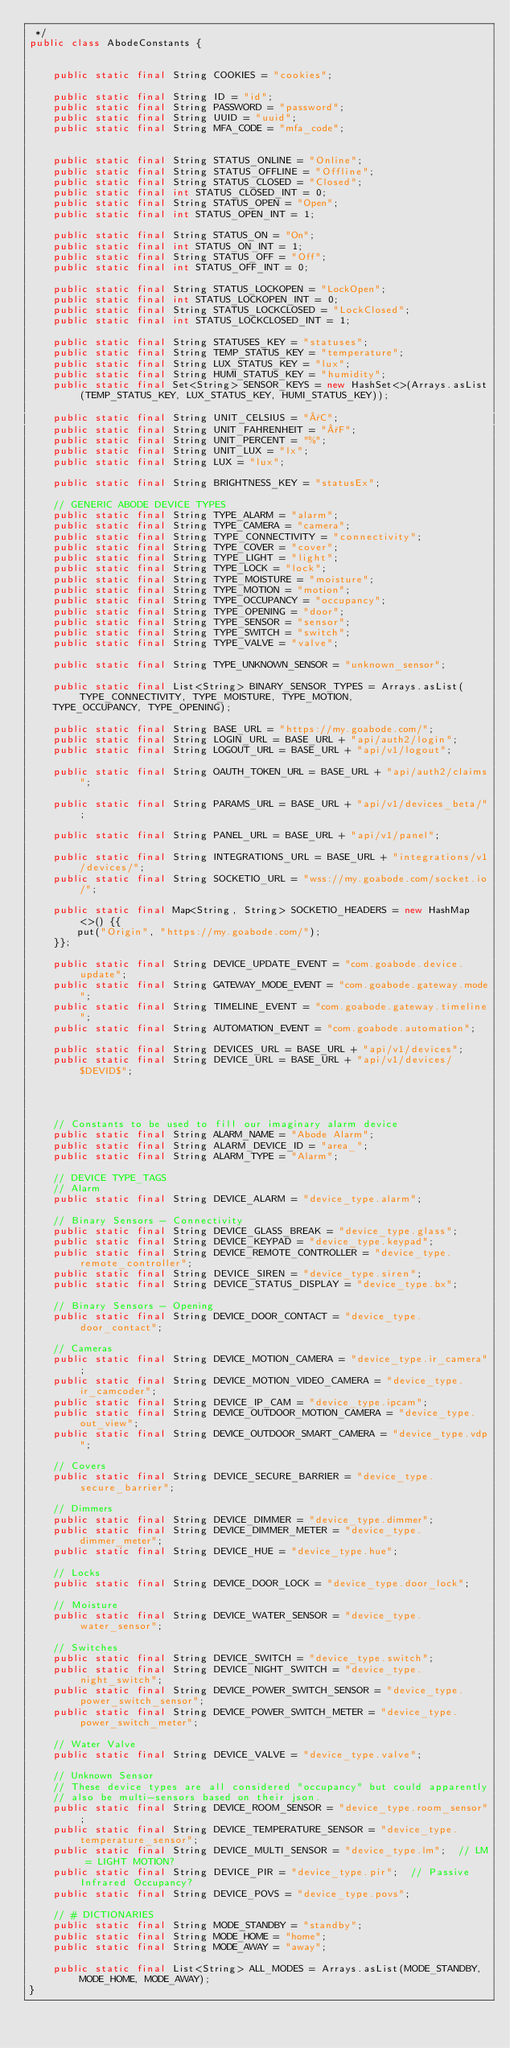Convert code to text. <code><loc_0><loc_0><loc_500><loc_500><_Java_> */
public class AbodeConstants {


    public static final String COOKIES = "cookies";

    public static final String ID = "id";
    public static final String PASSWORD = "password";
    public static final String UUID = "uuid";
    public static final String MFA_CODE = "mfa_code";


    public static final String STATUS_ONLINE = "Online";
    public static final String STATUS_OFFLINE = "Offline";
    public static final String STATUS_CLOSED = "Closed";
    public static final int STATUS_CLOSED_INT = 0;
    public static final String STATUS_OPEN = "Open";
    public static final int STATUS_OPEN_INT = 1;

    public static final String STATUS_ON = "On";
    public static final int STATUS_ON_INT = 1;
    public static final String STATUS_OFF = "Off";
    public static final int STATUS_OFF_INT = 0;

    public static final String STATUS_LOCKOPEN = "LockOpen";
    public static final int STATUS_LOCKOPEN_INT = 0;
    public static final String STATUS_LOCKCLOSED = "LockClosed";
    public static final int STATUS_LOCKCLOSED_INT = 1;

    public static final String STATUSES_KEY = "statuses";
    public static final String TEMP_STATUS_KEY = "temperature";
    public static final String LUX_STATUS_KEY = "lux";
    public static final String HUMI_STATUS_KEY = "humidity";
    public static final Set<String> SENSOR_KEYS = new HashSet<>(Arrays.asList(TEMP_STATUS_KEY, LUX_STATUS_KEY, HUMI_STATUS_KEY));

    public static final String UNIT_CELSIUS = "°C";
    public static final String UNIT_FAHRENHEIT = "°F";
    public static final String UNIT_PERCENT = "%";
    public static final String UNIT_LUX = "lx";
    public static final String LUX = "lux";

    public static final String BRIGHTNESS_KEY = "statusEx";

    // GENERIC ABODE DEVICE TYPES
    public static final String TYPE_ALARM = "alarm";
    public static final String TYPE_CAMERA = "camera";
    public static final String TYPE_CONNECTIVITY = "connectivity";
    public static final String TYPE_COVER = "cover";
    public static final String TYPE_LIGHT = "light";
    public static final String TYPE_LOCK = "lock";
    public static final String TYPE_MOISTURE = "moisture";
    public static final String TYPE_MOTION = "motion";
    public static final String TYPE_OCCUPANCY = "occupancy";
    public static final String TYPE_OPENING = "door";
    public static final String TYPE_SENSOR = "sensor";
    public static final String TYPE_SWITCH = "switch";
    public static final String TYPE_VALVE = "valve";

    public static final String TYPE_UNKNOWN_SENSOR = "unknown_sensor";

    public static final List<String> BINARY_SENSOR_TYPES = Arrays.asList(TYPE_CONNECTIVITY, TYPE_MOISTURE, TYPE_MOTION,
    TYPE_OCCUPANCY, TYPE_OPENING);

    public static final String BASE_URL = "https://my.goabode.com/";
    public static final String LOGIN_URL = BASE_URL + "api/auth2/login";
    public static final String LOGOUT_URL = BASE_URL + "api/v1/logout";

    public static final String OAUTH_TOKEN_URL = BASE_URL + "api/auth2/claims";

    public static final String PARAMS_URL = BASE_URL + "api/v1/devices_beta/";

    public static final String PANEL_URL = BASE_URL + "api/v1/panel";

    public static final String INTEGRATIONS_URL = BASE_URL + "integrations/v1/devices/";
    public static final String SOCKETIO_URL = "wss://my.goabode.com/socket.io/";

    public static final Map<String, String> SOCKETIO_HEADERS = new HashMap<>() {{
        put("Origin", "https://my.goabode.com/");
    }};

    public static final String DEVICE_UPDATE_EVENT = "com.goabode.device.update";
    public static final String GATEWAY_MODE_EVENT = "com.goabode.gateway.mode";
    public static final String TIMELINE_EVENT = "com.goabode.gateway.timeline";
    public static final String AUTOMATION_EVENT = "com.goabode.automation";

    public static final String DEVICES_URL = BASE_URL + "api/v1/devices";
    public static final String DEVICE_URL = BASE_URL + "api/v1/devices/$DEVID$";




    // Constants to be used to fill our imaginary alarm device
    public static final String ALARM_NAME = "Abode Alarm";
    public static final String ALARM_DEVICE_ID = "area_";
    public static final String ALARM_TYPE = "Alarm";
    
    // DEVICE TYPE_TAGS
    // Alarm
    public static final String DEVICE_ALARM = "device_type.alarm";

    // Binary Sensors - Connectivity
    public static final String DEVICE_GLASS_BREAK = "device_type.glass";
    public static final String DEVICE_KEYPAD = "device_type.keypad";
    public static final String DEVICE_REMOTE_CONTROLLER = "device_type.remote_controller";
    public static final String DEVICE_SIREN = "device_type.siren";
    public static final String DEVICE_STATUS_DISPLAY = "device_type.bx";

    // Binary Sensors - Opening
    public static final String DEVICE_DOOR_CONTACT = "device_type.door_contact";

    // Cameras
    public static final String DEVICE_MOTION_CAMERA = "device_type.ir_camera";
    public static final String DEVICE_MOTION_VIDEO_CAMERA = "device_type.ir_camcoder";
    public static final String DEVICE_IP_CAM = "device_type.ipcam";
    public static final String DEVICE_OUTDOOR_MOTION_CAMERA = "device_type.out_view";
    public static final String DEVICE_OUTDOOR_SMART_CAMERA = "device_type.vdp";

    // Covers
    public static final String DEVICE_SECURE_BARRIER = "device_type.secure_barrier";

    // Dimmers
    public static final String DEVICE_DIMMER = "device_type.dimmer";
    public static final String DEVICE_DIMMER_METER = "device_type.dimmer_meter";
    public static final String DEVICE_HUE = "device_type.hue";

    // Locks
    public static final String DEVICE_DOOR_LOCK = "device_type.door_lock";

    // Moisture
    public static final String DEVICE_WATER_SENSOR = "device_type.water_sensor";

    // Switches
    public static final String DEVICE_SWITCH = "device_type.switch";
    public static final String DEVICE_NIGHT_SWITCH = "device_type.night_switch";
    public static final String DEVICE_POWER_SWITCH_SENSOR = "device_type.power_switch_sensor";
    public static final String DEVICE_POWER_SWITCH_METER = "device_type.power_switch_meter";

    // Water Valve
    public static final String DEVICE_VALVE = "device_type.valve";

    // Unknown Sensor
    // These device types are all considered "occupancy" but could apparently
    // also be multi-sensors based on their json.
    public static final String DEVICE_ROOM_SENSOR = "device_type.room_sensor";
    public static final String DEVICE_TEMPERATURE_SENSOR = "device_type.temperature_sensor";
    public static final String DEVICE_MULTI_SENSOR = "device_type.lm";  // LM = LIGHT MOTION?
    public static final String DEVICE_PIR = "device_type.pir";  // Passive Infrared Occupancy?
    public static final String DEVICE_POVS = "device_type.povs";

    // # DICTIONARIES
    public static final String MODE_STANDBY = "standby";
    public static final String MODE_HOME = "home";
    public static final String MODE_AWAY = "away";

    public static final List<String> ALL_MODES = Arrays.asList(MODE_STANDBY, MODE_HOME, MODE_AWAY);
}
</code> 